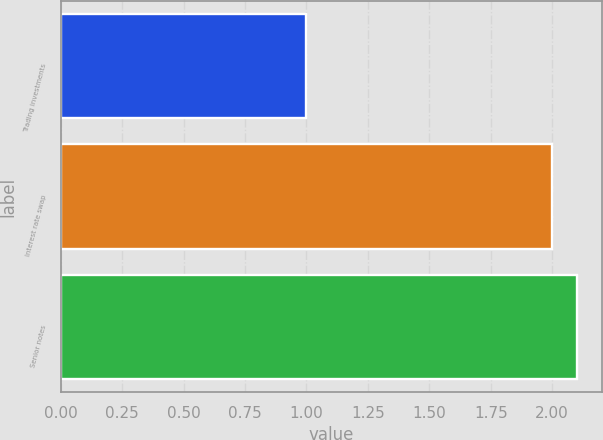Convert chart to OTSL. <chart><loc_0><loc_0><loc_500><loc_500><bar_chart><fcel>Trading investments<fcel>Interest rate swap<fcel>Senior notes<nl><fcel>1<fcel>2<fcel>2.1<nl></chart> 